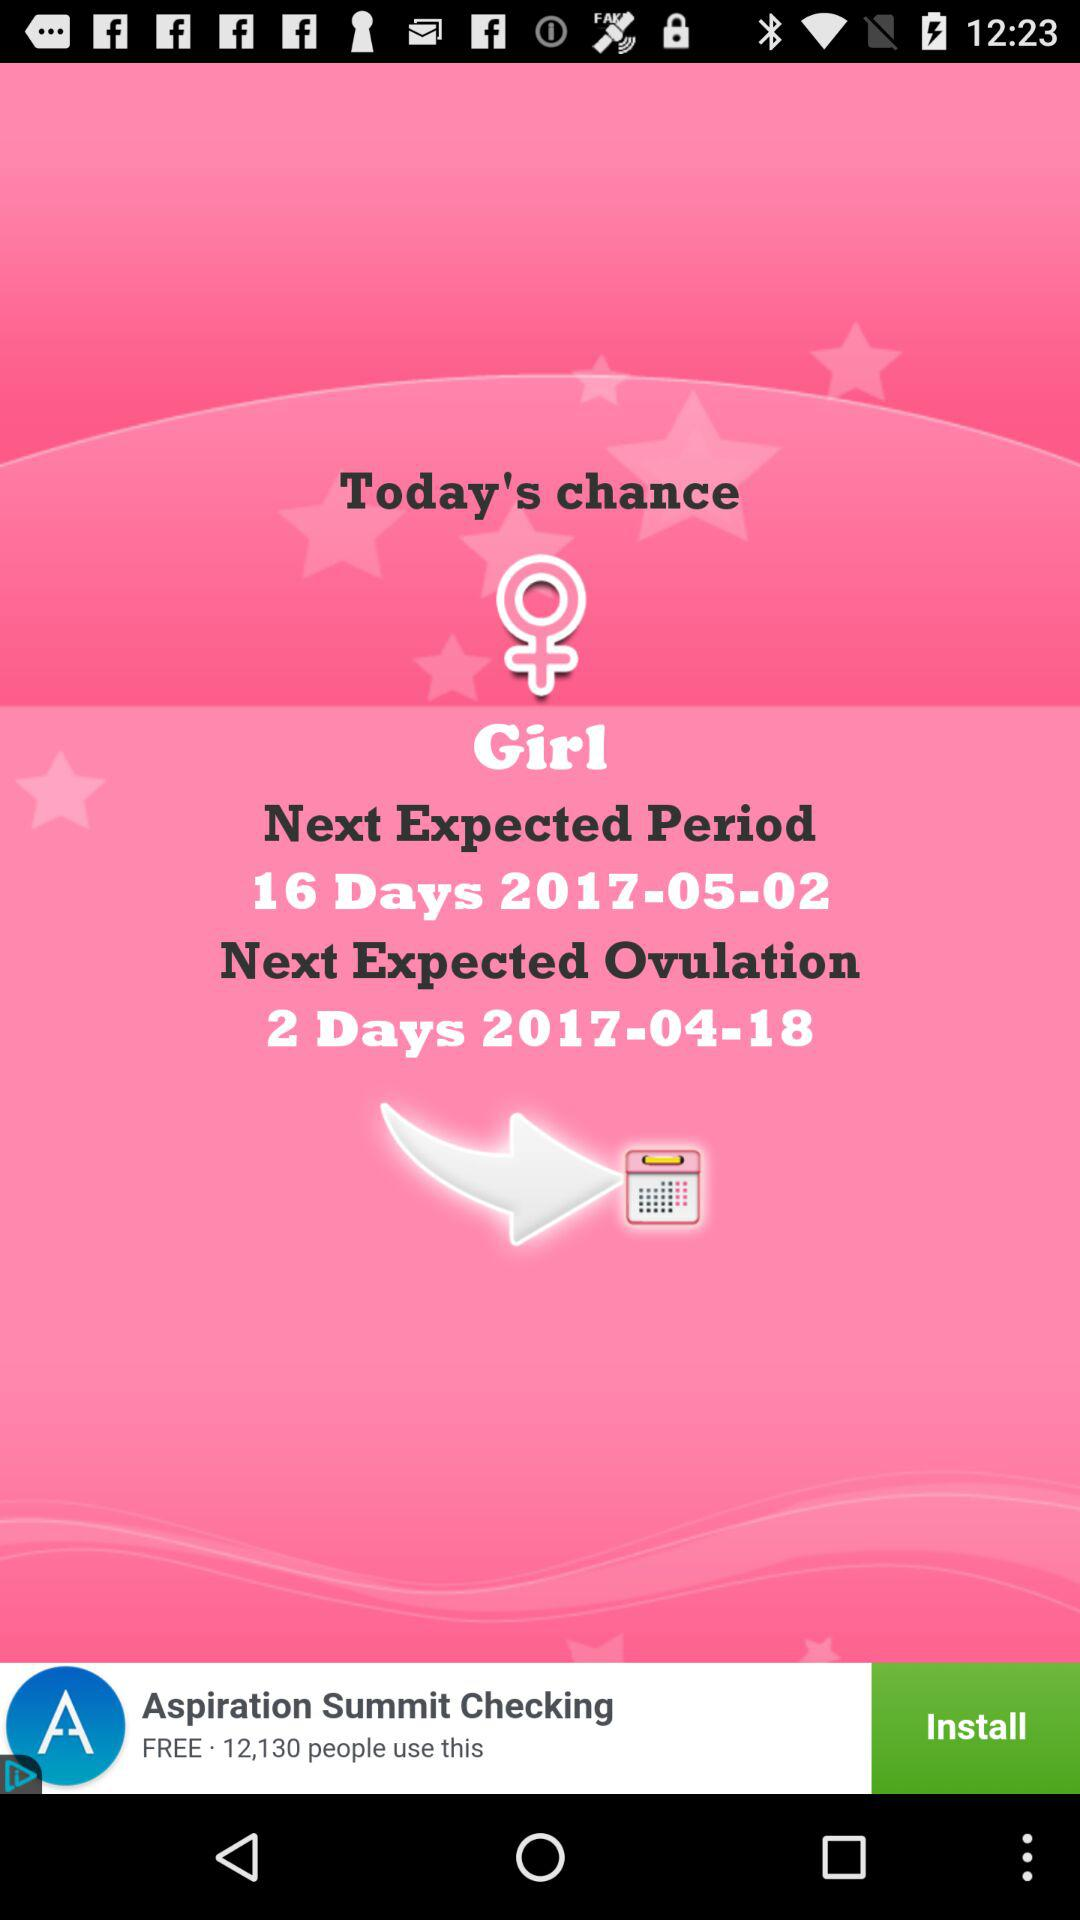What is the ovulation date? The ovulation date is April 18, 2017. 